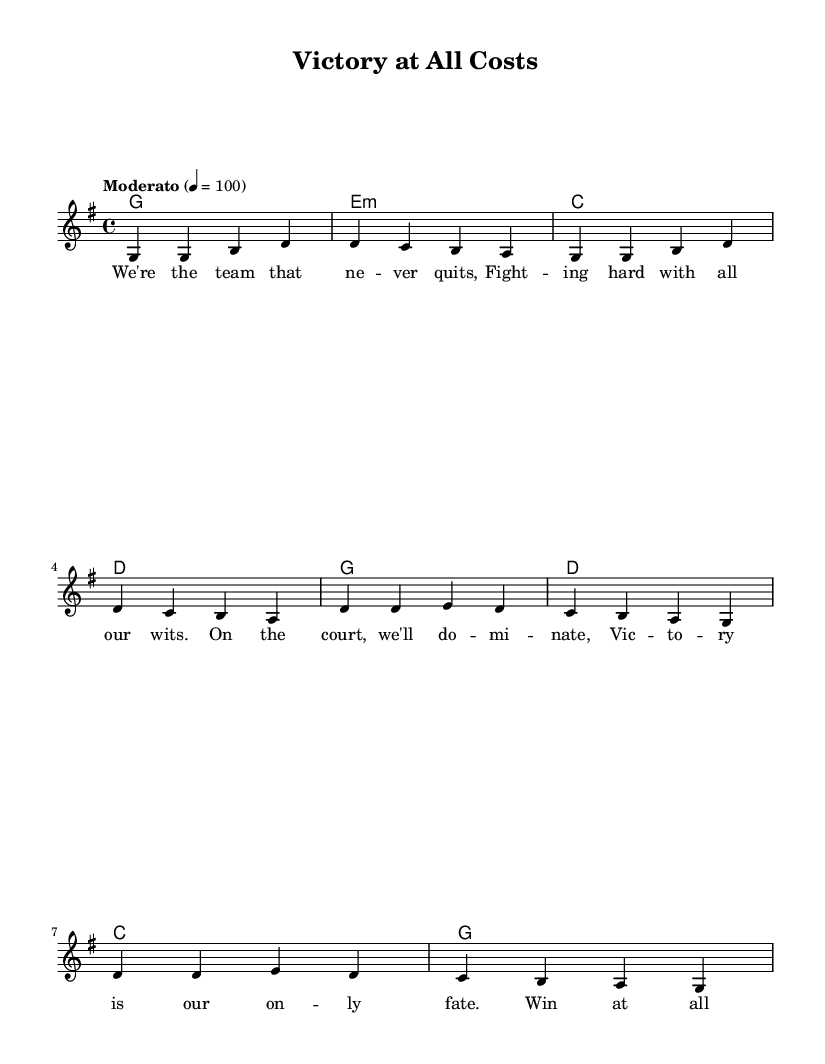What is the key signature of this music? The key signature is G major, which has one sharp (F#). This can be determined by identifying the key signature indicated at the beginning of the score.
Answer: G major What is the time signature of this music? The time signature indicated at the beginning of the score is 4/4, which means there are four beats in each measure and the quarter note gets one beat. This can be seen in the section where the time signature is written.
Answer: 4/4 What is the tempo marking? The tempo marking is "Moderato" with a metronome marking of 100 beats per minute. This is specified at the beginning of the score, indicating the speed at which the piece should be played.
Answer: Moderato How many verses are in the song? There is one verse indicated in the music sheet, as indicated by the structure where the lyric mode starts with the verse words before the chorus. The lyrics for the verse are placed before the chorus and are composed of four lines.
Answer: One What is the main theme of the lyrics? The main theme of the lyrics revolves around team spirit and determination to win, focusing on concepts such as fighting, dominance, and victory. By reading through the lyrics, both the verse and chorus highlight this competitive spirit and resolve.
Answer: Team spirit What chord is played during the chorus? The chords played during the chorus are G, D, C, and G, which are indicated in the chord mode section under the lyrics for the chorus. These chords provide the harmonic support for the melody during this part of the song.
Answer: G, D, C, G What is the phrase that repeats in the chorus? The phrase that repeats in the chorus is "Win at all costs, that's our way," which emphasizes the competitive nature of the team. This phrase is central to the song's message of determination and can be identified as the opening line of the chorus lyrics.
Answer: Win at all costs 